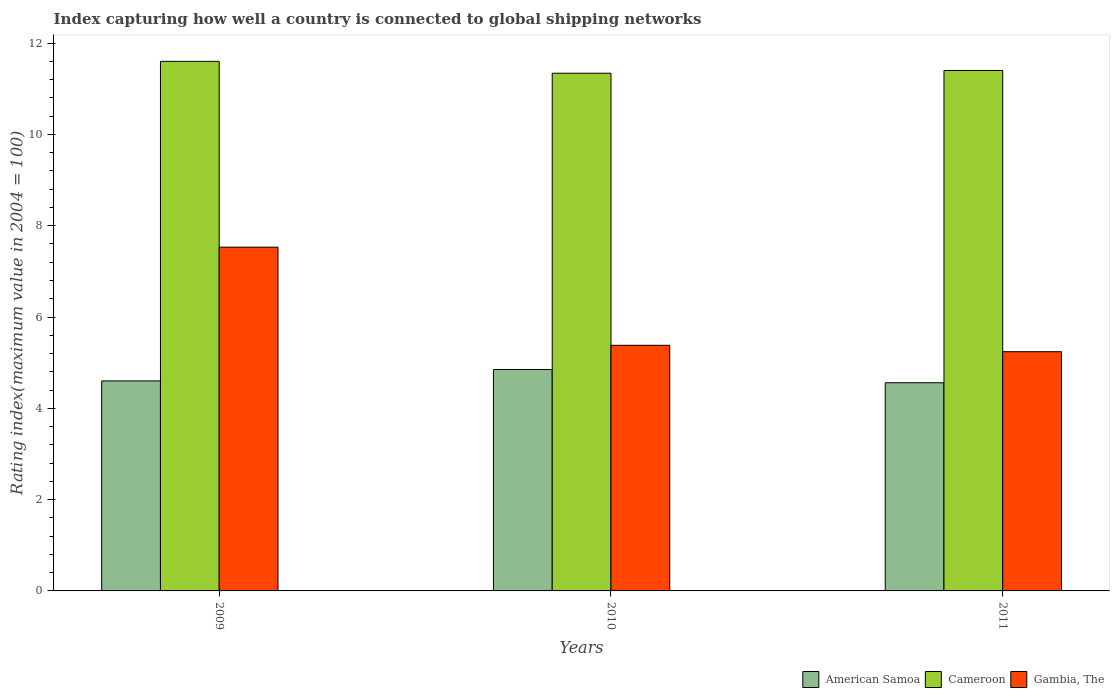How many groups of bars are there?
Provide a succinct answer. 3. Are the number of bars per tick equal to the number of legend labels?
Keep it short and to the point. Yes. How many bars are there on the 3rd tick from the left?
Offer a very short reply. 3. What is the label of the 1st group of bars from the left?
Provide a succinct answer. 2009. In how many cases, is the number of bars for a given year not equal to the number of legend labels?
Make the answer very short. 0. What is the rating index in American Samoa in 2011?
Offer a very short reply. 4.56. Across all years, what is the maximum rating index in Gambia, The?
Provide a short and direct response. 7.53. Across all years, what is the minimum rating index in Gambia, The?
Keep it short and to the point. 5.24. In which year was the rating index in American Samoa maximum?
Your answer should be very brief. 2010. In which year was the rating index in American Samoa minimum?
Your answer should be compact. 2011. What is the total rating index in Cameroon in the graph?
Offer a terse response. 34.34. What is the difference between the rating index in American Samoa in 2010 and that in 2011?
Offer a terse response. 0.29. What is the difference between the rating index in Cameroon in 2010 and the rating index in Gambia, The in 2009?
Keep it short and to the point. 3.81. What is the average rating index in Cameroon per year?
Ensure brevity in your answer.  11.45. In the year 2010, what is the difference between the rating index in Gambia, The and rating index in Cameroon?
Your answer should be very brief. -5.96. In how many years, is the rating index in American Samoa greater than 10?
Provide a succinct answer. 0. What is the ratio of the rating index in American Samoa in 2010 to that in 2011?
Ensure brevity in your answer.  1.06. Is the difference between the rating index in Gambia, The in 2009 and 2010 greater than the difference between the rating index in Cameroon in 2009 and 2010?
Offer a terse response. Yes. What is the difference between the highest and the lowest rating index in American Samoa?
Provide a short and direct response. 0.29. In how many years, is the rating index in Gambia, The greater than the average rating index in Gambia, The taken over all years?
Your answer should be very brief. 1. Is the sum of the rating index in American Samoa in 2009 and 2011 greater than the maximum rating index in Cameroon across all years?
Your answer should be compact. No. What does the 2nd bar from the left in 2011 represents?
Make the answer very short. Cameroon. What does the 2nd bar from the right in 2010 represents?
Your answer should be very brief. Cameroon. Is it the case that in every year, the sum of the rating index in Gambia, The and rating index in Cameroon is greater than the rating index in American Samoa?
Offer a very short reply. Yes. How many bars are there?
Keep it short and to the point. 9. How many years are there in the graph?
Your answer should be compact. 3. What is the difference between two consecutive major ticks on the Y-axis?
Offer a terse response. 2. Are the values on the major ticks of Y-axis written in scientific E-notation?
Offer a very short reply. No. How many legend labels are there?
Offer a terse response. 3. How are the legend labels stacked?
Provide a short and direct response. Horizontal. What is the title of the graph?
Keep it short and to the point. Index capturing how well a country is connected to global shipping networks. Does "St. Lucia" appear as one of the legend labels in the graph?
Provide a succinct answer. No. What is the label or title of the Y-axis?
Provide a short and direct response. Rating index(maximum value in 2004 = 100). What is the Rating index(maximum value in 2004 = 100) in American Samoa in 2009?
Your answer should be very brief. 4.6. What is the Rating index(maximum value in 2004 = 100) of Cameroon in 2009?
Make the answer very short. 11.6. What is the Rating index(maximum value in 2004 = 100) of Gambia, The in 2009?
Keep it short and to the point. 7.53. What is the Rating index(maximum value in 2004 = 100) of American Samoa in 2010?
Provide a short and direct response. 4.85. What is the Rating index(maximum value in 2004 = 100) of Cameroon in 2010?
Give a very brief answer. 11.34. What is the Rating index(maximum value in 2004 = 100) in Gambia, The in 2010?
Keep it short and to the point. 5.38. What is the Rating index(maximum value in 2004 = 100) in American Samoa in 2011?
Provide a short and direct response. 4.56. What is the Rating index(maximum value in 2004 = 100) in Gambia, The in 2011?
Give a very brief answer. 5.24. Across all years, what is the maximum Rating index(maximum value in 2004 = 100) in American Samoa?
Make the answer very short. 4.85. Across all years, what is the maximum Rating index(maximum value in 2004 = 100) of Cameroon?
Provide a short and direct response. 11.6. Across all years, what is the maximum Rating index(maximum value in 2004 = 100) of Gambia, The?
Ensure brevity in your answer.  7.53. Across all years, what is the minimum Rating index(maximum value in 2004 = 100) in American Samoa?
Keep it short and to the point. 4.56. Across all years, what is the minimum Rating index(maximum value in 2004 = 100) in Cameroon?
Keep it short and to the point. 11.34. Across all years, what is the minimum Rating index(maximum value in 2004 = 100) in Gambia, The?
Offer a terse response. 5.24. What is the total Rating index(maximum value in 2004 = 100) of American Samoa in the graph?
Give a very brief answer. 14.01. What is the total Rating index(maximum value in 2004 = 100) in Cameroon in the graph?
Your response must be concise. 34.34. What is the total Rating index(maximum value in 2004 = 100) in Gambia, The in the graph?
Keep it short and to the point. 18.15. What is the difference between the Rating index(maximum value in 2004 = 100) in American Samoa in 2009 and that in 2010?
Offer a very short reply. -0.25. What is the difference between the Rating index(maximum value in 2004 = 100) of Cameroon in 2009 and that in 2010?
Provide a succinct answer. 0.26. What is the difference between the Rating index(maximum value in 2004 = 100) of Gambia, The in 2009 and that in 2010?
Your response must be concise. 2.15. What is the difference between the Rating index(maximum value in 2004 = 100) of Gambia, The in 2009 and that in 2011?
Provide a short and direct response. 2.29. What is the difference between the Rating index(maximum value in 2004 = 100) of American Samoa in 2010 and that in 2011?
Provide a succinct answer. 0.29. What is the difference between the Rating index(maximum value in 2004 = 100) in Cameroon in 2010 and that in 2011?
Offer a very short reply. -0.06. What is the difference between the Rating index(maximum value in 2004 = 100) in Gambia, The in 2010 and that in 2011?
Your answer should be compact. 0.14. What is the difference between the Rating index(maximum value in 2004 = 100) of American Samoa in 2009 and the Rating index(maximum value in 2004 = 100) of Cameroon in 2010?
Offer a very short reply. -6.74. What is the difference between the Rating index(maximum value in 2004 = 100) of American Samoa in 2009 and the Rating index(maximum value in 2004 = 100) of Gambia, The in 2010?
Your answer should be compact. -0.78. What is the difference between the Rating index(maximum value in 2004 = 100) in Cameroon in 2009 and the Rating index(maximum value in 2004 = 100) in Gambia, The in 2010?
Ensure brevity in your answer.  6.22. What is the difference between the Rating index(maximum value in 2004 = 100) of American Samoa in 2009 and the Rating index(maximum value in 2004 = 100) of Gambia, The in 2011?
Provide a succinct answer. -0.64. What is the difference between the Rating index(maximum value in 2004 = 100) of Cameroon in 2009 and the Rating index(maximum value in 2004 = 100) of Gambia, The in 2011?
Your answer should be very brief. 6.36. What is the difference between the Rating index(maximum value in 2004 = 100) of American Samoa in 2010 and the Rating index(maximum value in 2004 = 100) of Cameroon in 2011?
Give a very brief answer. -6.55. What is the difference between the Rating index(maximum value in 2004 = 100) in American Samoa in 2010 and the Rating index(maximum value in 2004 = 100) in Gambia, The in 2011?
Offer a very short reply. -0.39. What is the average Rating index(maximum value in 2004 = 100) in American Samoa per year?
Keep it short and to the point. 4.67. What is the average Rating index(maximum value in 2004 = 100) in Cameroon per year?
Offer a very short reply. 11.45. What is the average Rating index(maximum value in 2004 = 100) in Gambia, The per year?
Offer a terse response. 6.05. In the year 2009, what is the difference between the Rating index(maximum value in 2004 = 100) of American Samoa and Rating index(maximum value in 2004 = 100) of Gambia, The?
Provide a succinct answer. -2.93. In the year 2009, what is the difference between the Rating index(maximum value in 2004 = 100) of Cameroon and Rating index(maximum value in 2004 = 100) of Gambia, The?
Your answer should be very brief. 4.07. In the year 2010, what is the difference between the Rating index(maximum value in 2004 = 100) in American Samoa and Rating index(maximum value in 2004 = 100) in Cameroon?
Provide a succinct answer. -6.49. In the year 2010, what is the difference between the Rating index(maximum value in 2004 = 100) of American Samoa and Rating index(maximum value in 2004 = 100) of Gambia, The?
Offer a terse response. -0.53. In the year 2010, what is the difference between the Rating index(maximum value in 2004 = 100) in Cameroon and Rating index(maximum value in 2004 = 100) in Gambia, The?
Offer a terse response. 5.96. In the year 2011, what is the difference between the Rating index(maximum value in 2004 = 100) of American Samoa and Rating index(maximum value in 2004 = 100) of Cameroon?
Ensure brevity in your answer.  -6.84. In the year 2011, what is the difference between the Rating index(maximum value in 2004 = 100) of American Samoa and Rating index(maximum value in 2004 = 100) of Gambia, The?
Give a very brief answer. -0.68. In the year 2011, what is the difference between the Rating index(maximum value in 2004 = 100) of Cameroon and Rating index(maximum value in 2004 = 100) of Gambia, The?
Your answer should be compact. 6.16. What is the ratio of the Rating index(maximum value in 2004 = 100) in American Samoa in 2009 to that in 2010?
Provide a short and direct response. 0.95. What is the ratio of the Rating index(maximum value in 2004 = 100) of Cameroon in 2009 to that in 2010?
Offer a terse response. 1.02. What is the ratio of the Rating index(maximum value in 2004 = 100) in Gambia, The in 2009 to that in 2010?
Provide a succinct answer. 1.4. What is the ratio of the Rating index(maximum value in 2004 = 100) in American Samoa in 2009 to that in 2011?
Offer a very short reply. 1.01. What is the ratio of the Rating index(maximum value in 2004 = 100) of Cameroon in 2009 to that in 2011?
Provide a short and direct response. 1.02. What is the ratio of the Rating index(maximum value in 2004 = 100) in Gambia, The in 2009 to that in 2011?
Your response must be concise. 1.44. What is the ratio of the Rating index(maximum value in 2004 = 100) of American Samoa in 2010 to that in 2011?
Your response must be concise. 1.06. What is the ratio of the Rating index(maximum value in 2004 = 100) in Gambia, The in 2010 to that in 2011?
Offer a terse response. 1.03. What is the difference between the highest and the second highest Rating index(maximum value in 2004 = 100) of Gambia, The?
Offer a terse response. 2.15. What is the difference between the highest and the lowest Rating index(maximum value in 2004 = 100) in American Samoa?
Provide a succinct answer. 0.29. What is the difference between the highest and the lowest Rating index(maximum value in 2004 = 100) in Cameroon?
Your answer should be compact. 0.26. What is the difference between the highest and the lowest Rating index(maximum value in 2004 = 100) in Gambia, The?
Your answer should be compact. 2.29. 